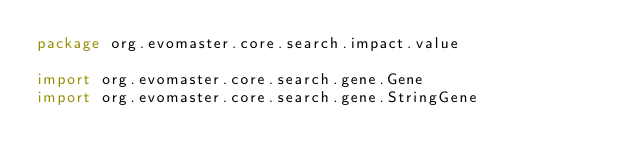Convert code to text. <code><loc_0><loc_0><loc_500><loc_500><_Kotlin_>package org.evomaster.core.search.impact.value

import org.evomaster.core.search.gene.Gene
import org.evomaster.core.search.gene.StringGene</code> 